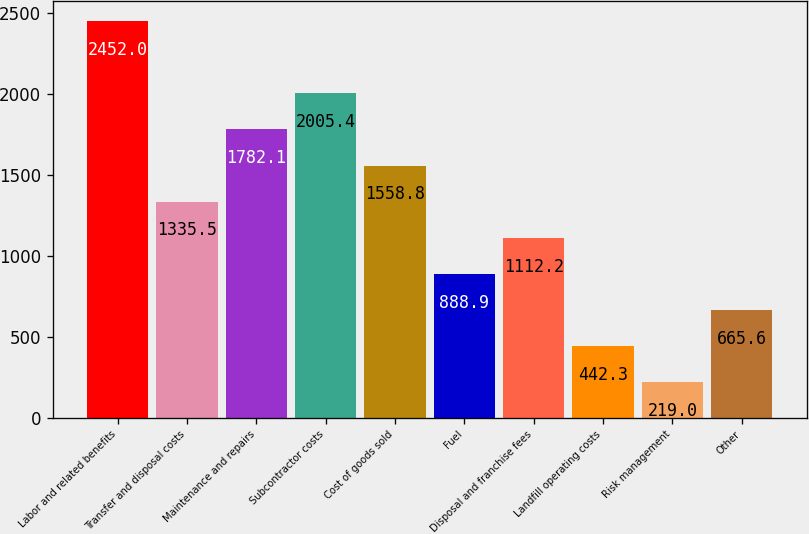<chart> <loc_0><loc_0><loc_500><loc_500><bar_chart><fcel>Labor and related benefits<fcel>Transfer and disposal costs<fcel>Maintenance and repairs<fcel>Subcontractor costs<fcel>Cost of goods sold<fcel>Fuel<fcel>Disposal and franchise fees<fcel>Landfill operating costs<fcel>Risk management<fcel>Other<nl><fcel>2452<fcel>1335.5<fcel>1782.1<fcel>2005.4<fcel>1558.8<fcel>888.9<fcel>1112.2<fcel>442.3<fcel>219<fcel>665.6<nl></chart> 